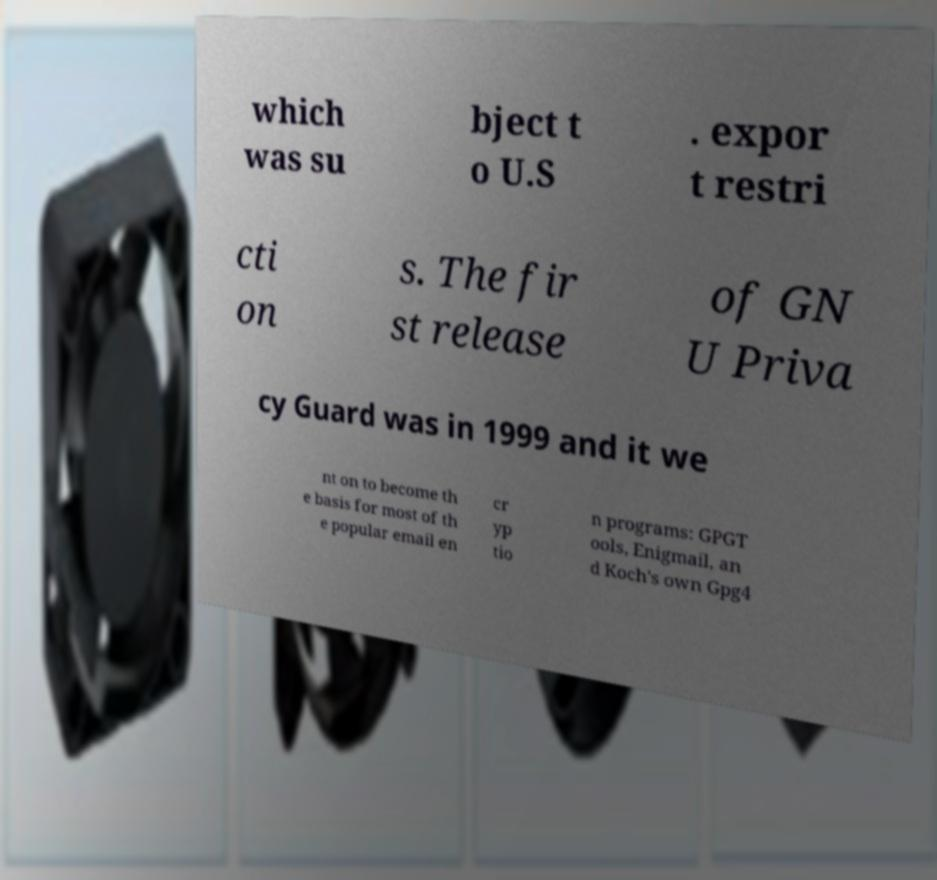Could you assist in decoding the text presented in this image and type it out clearly? which was su bject t o U.S . expor t restri cti on s. The fir st release of GN U Priva cy Guard was in 1999 and it we nt on to become th e basis for most of th e popular email en cr yp tio n programs: GPGT ools, Enigmail, an d Koch's own Gpg4 